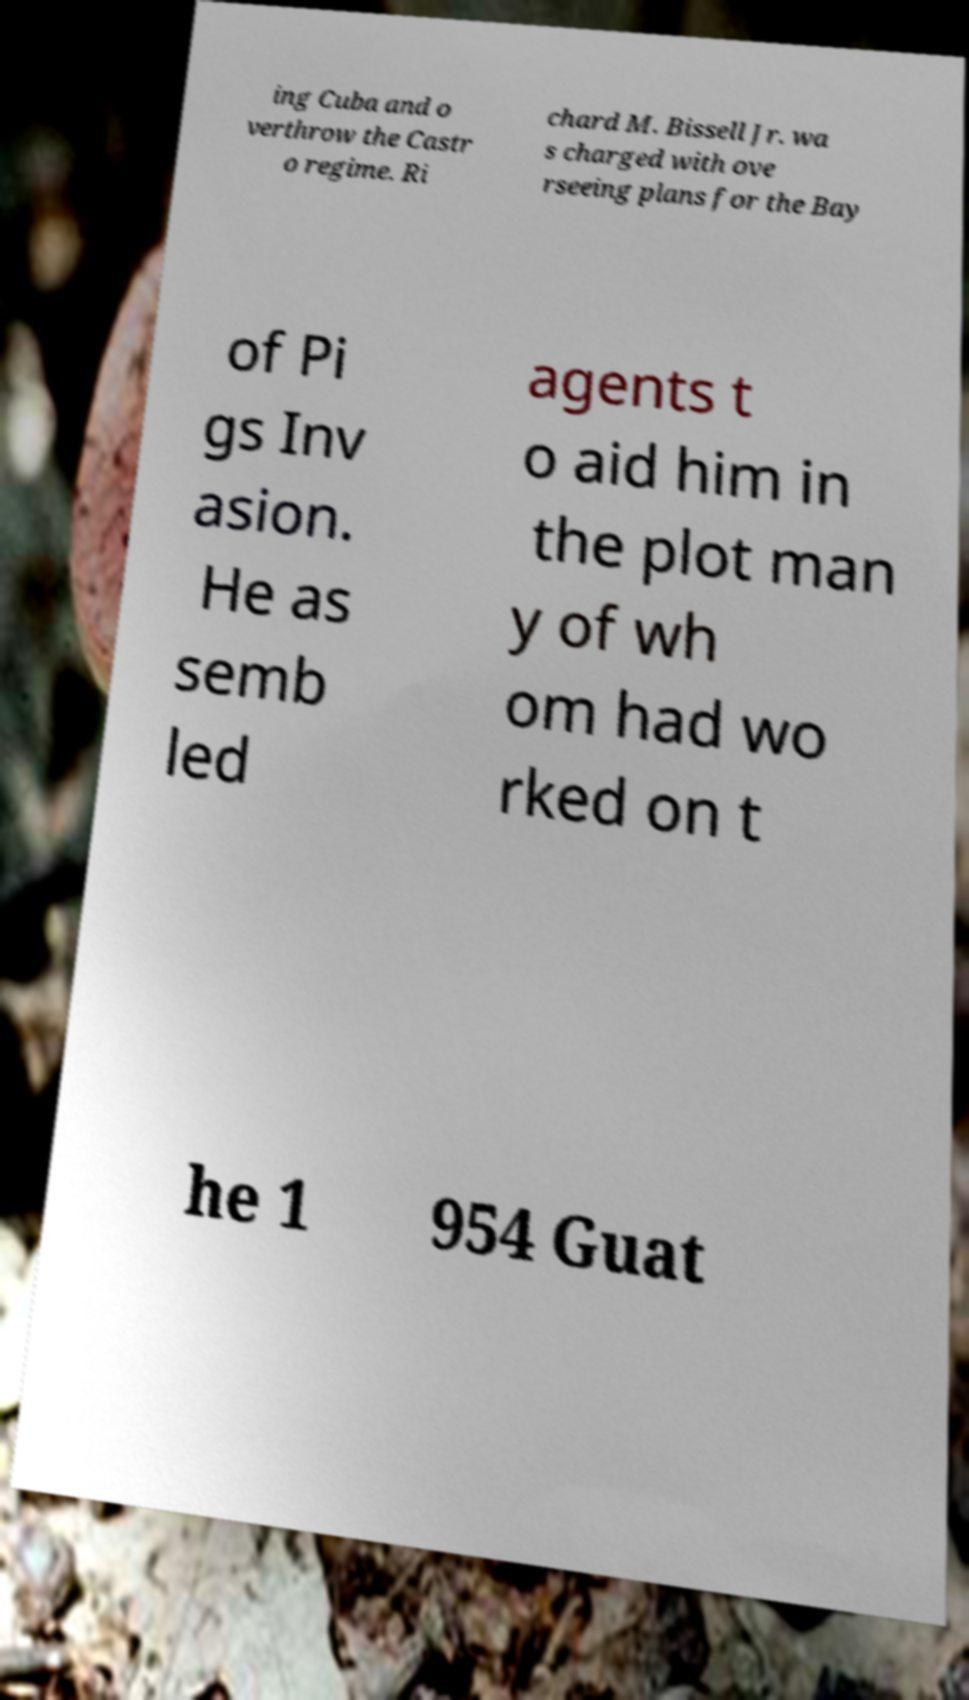Can you accurately transcribe the text from the provided image for me? ing Cuba and o verthrow the Castr o regime. Ri chard M. Bissell Jr. wa s charged with ove rseeing plans for the Bay of Pi gs Inv asion. He as semb led agents t o aid him in the plot man y of wh om had wo rked on t he 1 954 Guat 